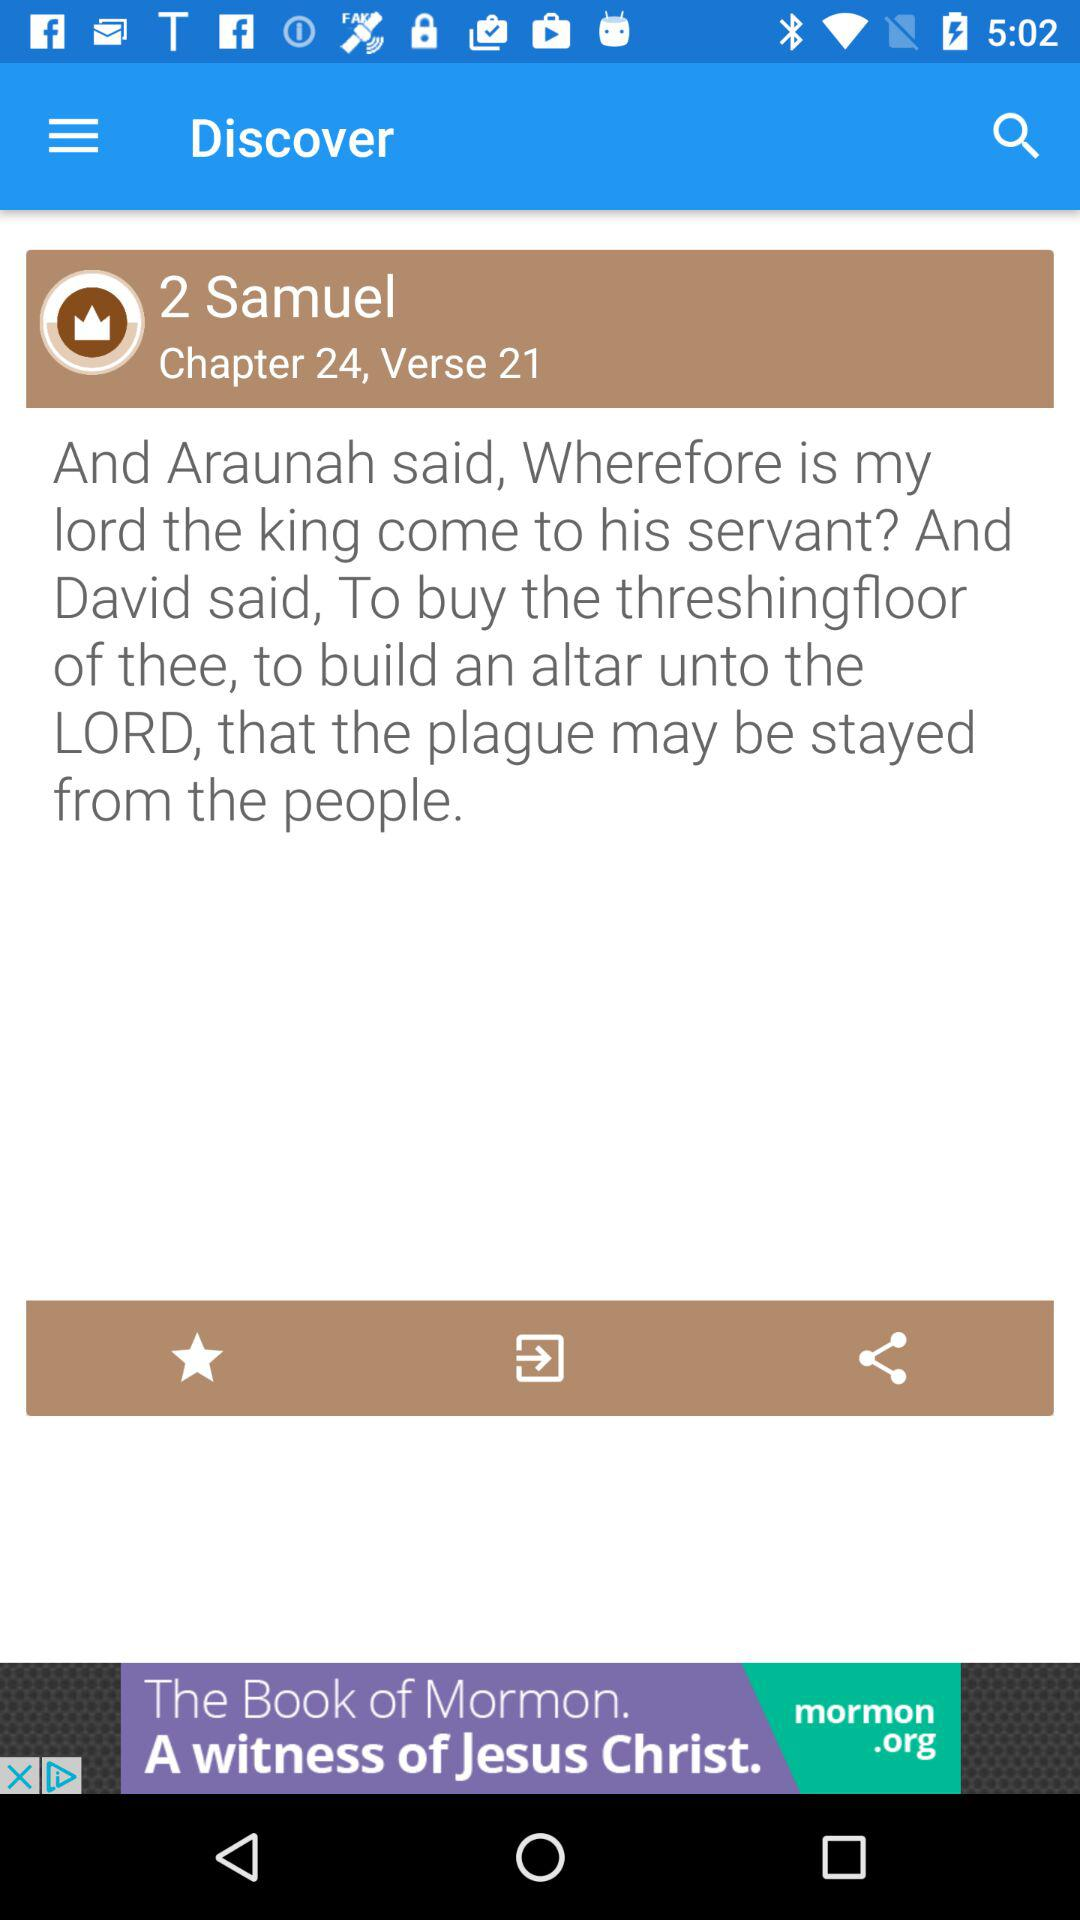Who is the writer of the chapter?
When the provided information is insufficient, respond with <no answer>. <no answer> 